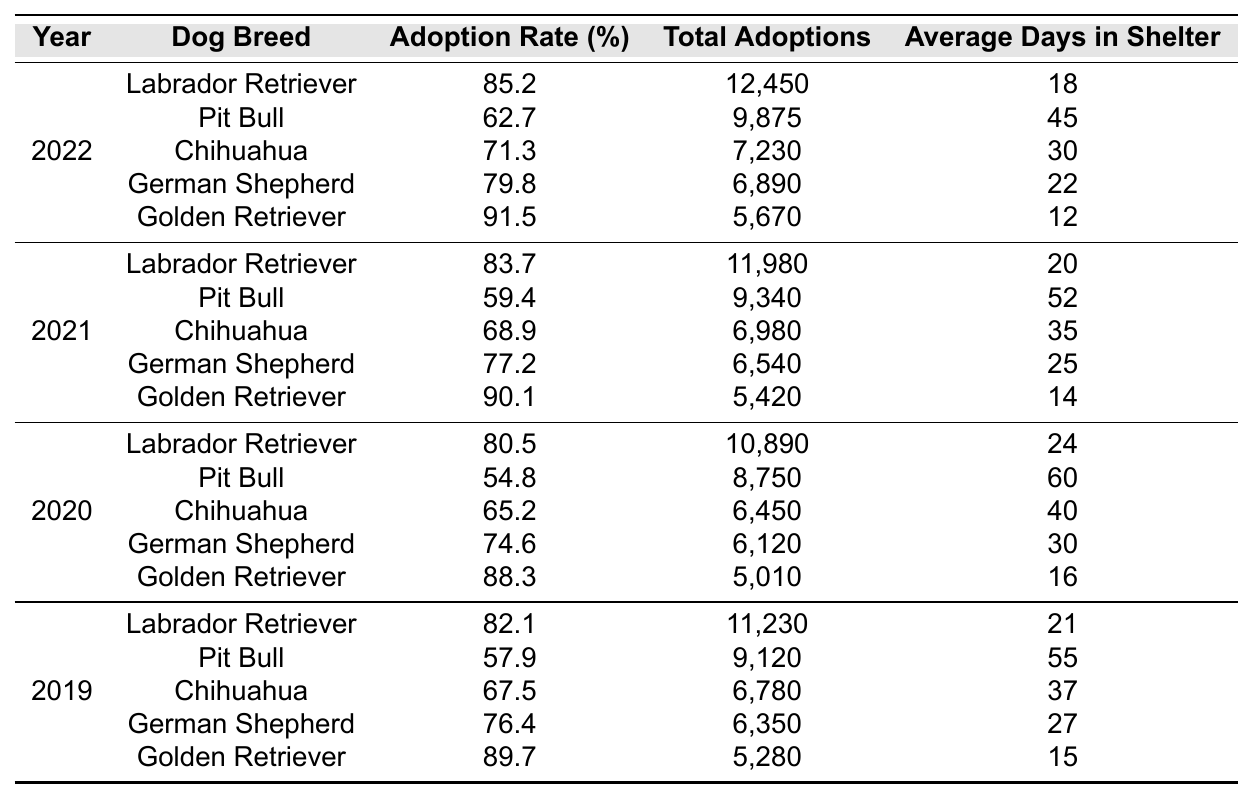What was the adoption rate for Golden Retrievers in 2022? The table shows that the adoption rate for Golden Retrievers in 2022 is 91.5%.
Answer: 91.5% Which breed had the highest total adoptions in 2021? Looking at the 2021 data, Labrador Retrievers had the highest total adoptions with 11,980.
Answer: Labrador Retriever How many average days did Pit Bulls spend in the shelter in 2020? The average days in shelter for Pit Bulls in 2020 is 60 days as per the data provided.
Answer: 60 days What is the difference in adoption rates between the Labrador Retriever in 2021 and 2022? The adoption rate for Labrador Retrievers was 83.7% in 2021 and 85.2% in 2022. The difference is 85.2% - 83.7% = 1.5%.
Answer: 1.5% Did the adoption rate of Chihuahuas increase from 2019 to 2021? In 2019, the adoption rate for Chihuahuas was 67.5% and in 2021 it was 68.9%, which means it did increase.
Answer: Yes What was the average adoption rate of the Golden Retriever across all available years? The rates for Golden Retrievers are 88.3% (2020), 90.1% (2021), and 91.5% (2022). Summing these gives 88.3 + 90.1 + 91.5 = 270. The average is 270 / 3 = 90.
Answer: 90% Which breed saw the lowest adoption rate in 2022 and what was that rate? The Pit Bull had the lowest adoption rate in 2022, which was 62.7%.
Answer: Pit Bull, 62.7% How many total adoptions were there for German Shepherds across all four years? The total adoptions for German Shepherds are 6,350 (2019) + 6,120 (2020) + 6,540 (2021) + 6,890 (2022) = 25,900 total adoptions.
Answer: 25,900 What is the trend for the average days in shelter for the Chihuahua breed from 2019 to 2022? The average days in shelter for Chihuahuas were 37 days (2019), 35 days (2021), and 30 days (2022), showing a decreasing trend.
Answer: Decreasing trend Did the total adoptions for Pit Bulls increase or decrease from 2019 to 2022? The total adoptions decreased from 9,120 in 2019 to 9,875 in 2022, indicating an increase.
Answer: Increased What is the average number of days in shelter for all breeds in 2022? The average days calculation is (18 + 45 + 30 + 22 + 12) / 5 = 25.4 days.
Answer: 25.4 days 